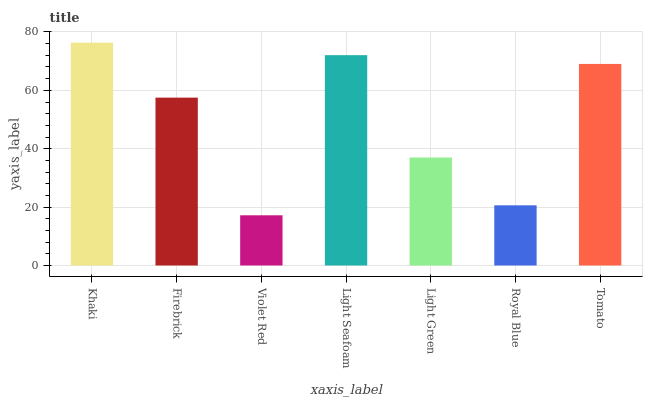Is Violet Red the minimum?
Answer yes or no. Yes. Is Khaki the maximum?
Answer yes or no. Yes. Is Firebrick the minimum?
Answer yes or no. No. Is Firebrick the maximum?
Answer yes or no. No. Is Khaki greater than Firebrick?
Answer yes or no. Yes. Is Firebrick less than Khaki?
Answer yes or no. Yes. Is Firebrick greater than Khaki?
Answer yes or no. No. Is Khaki less than Firebrick?
Answer yes or no. No. Is Firebrick the high median?
Answer yes or no. Yes. Is Firebrick the low median?
Answer yes or no. Yes. Is Royal Blue the high median?
Answer yes or no. No. Is Violet Red the low median?
Answer yes or no. No. 